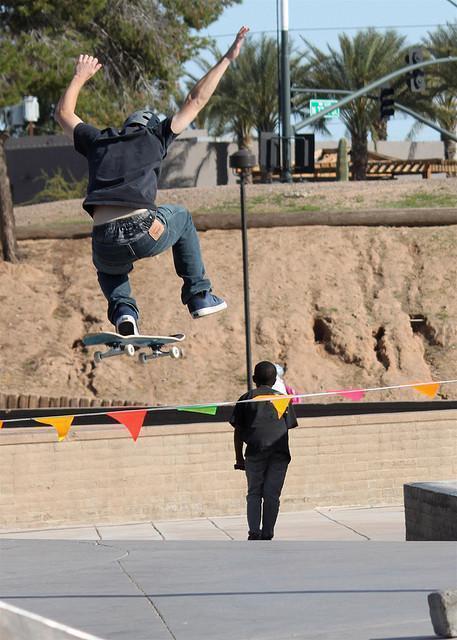In what setting is the skater skating?
Indicate the correct choice and explain in the format: 'Answer: answer
Rationale: rationale.'
Options: Desert, oceanic, farm, urban. Answer: urban.
Rationale: A skateboarder is doing a trick and there is pavement, houses, and other people around. 